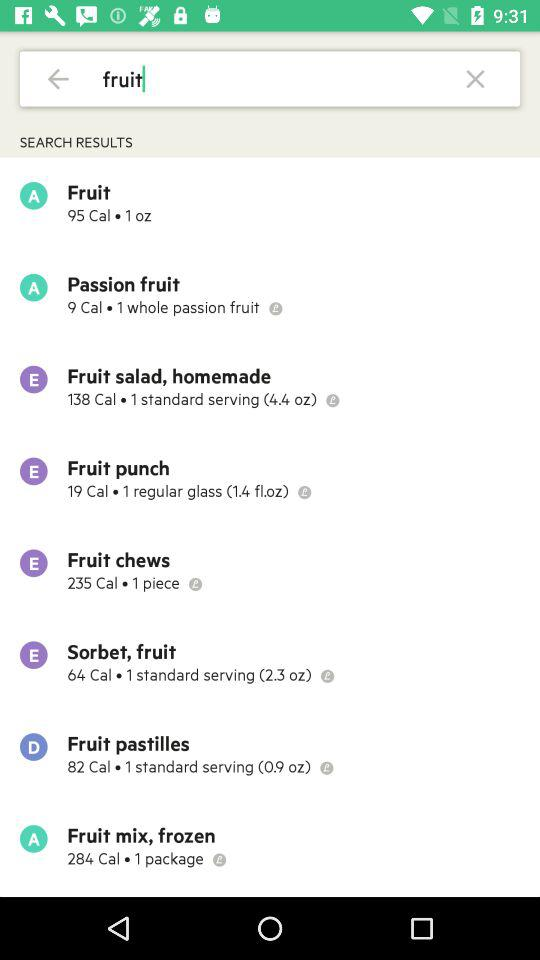How many calories are in the "Fruit punch" salad? The "Fruit punch" salad has 19 calories. 